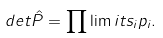Convert formula to latex. <formula><loc_0><loc_0><loc_500><loc_500>d e t \hat { P } = \prod \lim i t s _ { i } p _ { i } .</formula> 